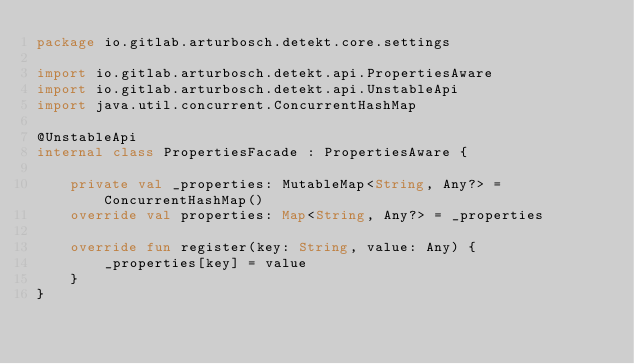Convert code to text. <code><loc_0><loc_0><loc_500><loc_500><_Kotlin_>package io.gitlab.arturbosch.detekt.core.settings

import io.gitlab.arturbosch.detekt.api.PropertiesAware
import io.gitlab.arturbosch.detekt.api.UnstableApi
import java.util.concurrent.ConcurrentHashMap

@UnstableApi
internal class PropertiesFacade : PropertiesAware {

    private val _properties: MutableMap<String, Any?> = ConcurrentHashMap()
    override val properties: Map<String, Any?> = _properties

    override fun register(key: String, value: Any) {
        _properties[key] = value
    }
}
</code> 